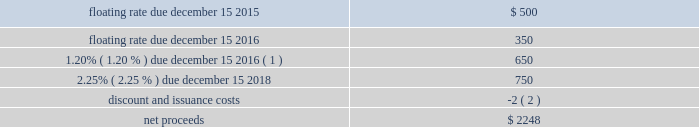Devon energy corporation and subsidiaries notes to consolidated financial statements 2013 ( continued ) other debentures and notes following are descriptions of the various other debentures and notes outstanding at december 31 , 2014 and 2013 , as listed in the table presented at the beginning of this note .
Geosouthern debt in december 2013 , in conjunction with the planned geosouthern acquisition , devon issued $ 2.25 billion aggregate principal amount of fixed and floating rate senior notes resulting in cash proceeds of approximately $ 2.2 billion , net of discounts and issuance costs .
The floating rate senior notes due in 2015 bear interest at a rate equal to three-month libor plus 0.45 percent , which rate will be reset quarterly .
The floating rate senior notes due in 2016 bears interest at a rate equal to three-month libor plus 0.54 percent , which rate will be reset quarterly .
The schedule below summarizes the key terms of these notes ( in millions ) . .
( 1 ) the 1.20% ( 1.20 % ) $ 650 million note due december 15 , 2016 was redeemed on november 13 , 2014 .
The senior notes were classified as short-term debt on devon 2019s consolidated balance sheet as of december 31 , 2013 due to certain redemption features in the event that the geosouthern acquisition was not completed on or prior to june 30 , 2014 .
On february 28 , 2014 , the geosouthern acquisition closed and thus the senior notes were subsequently classified as long-term debt .
Additionally , during december 2013 , devon entered into a term loan agreement with a group of major financial institutions pursuant to which devon could draw up to $ 2.0 billion to finance , in part , the geosouthern acquisition and to pay transaction costs .
In february 2014 , devon drew the $ 2.0 billion of term loans for the geosouthern transaction , and the amount was subsequently repaid on june 30 , 2014 with the canadian divestiture proceeds that were repatriated to the u.s .
In june 2014 , at which point the term loan was terminated. .
Debt in december 2013 , what was the percent of the net of discounts and issuance costs associated with the issuance fixed and floating rate senior notes in conjunction with the planned geosouthern acquisition? 
Computations: ((2.25 - 2.2) / 2.2)
Answer: 0.02273. 